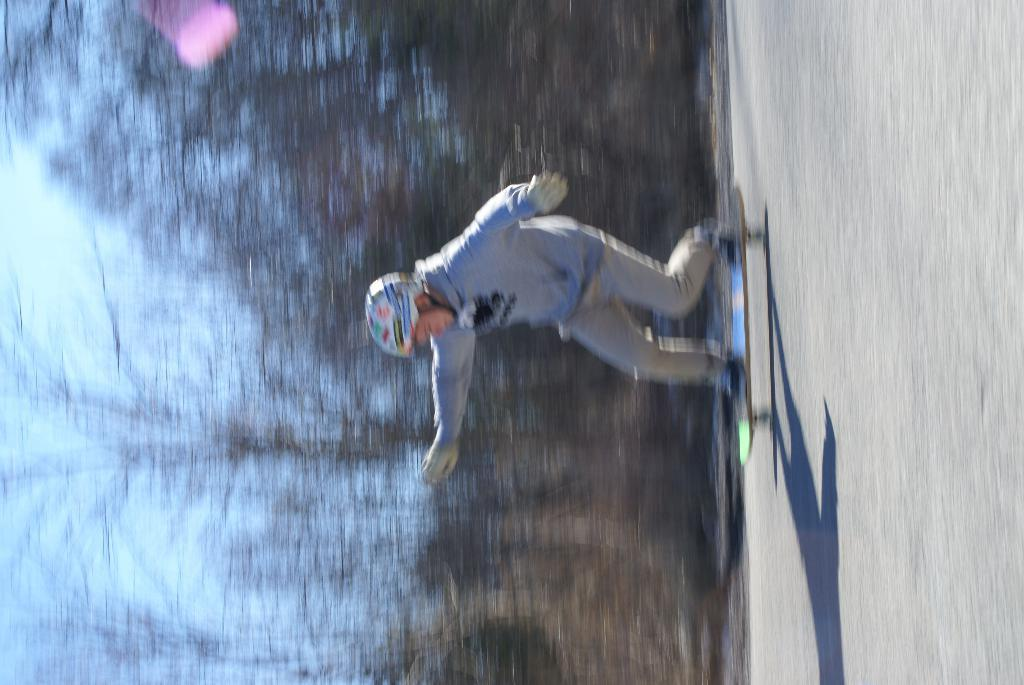What is the person in the image doing? The person is skating on a skateboard in the image. What type of clothing is the person wearing on their upper body? The person is wearing a sweater in the image. What type of clothing is the person wearing on their lower body? The person is wearing trousers in the image. What safety gear is the person wearing? The person is wearing a helmet in the image. What can be seen in the background of the image? There are trees in the image. How far does the ice travel in the image? There is no ice present in the image, so it is not possible to determine how far it might travel. 